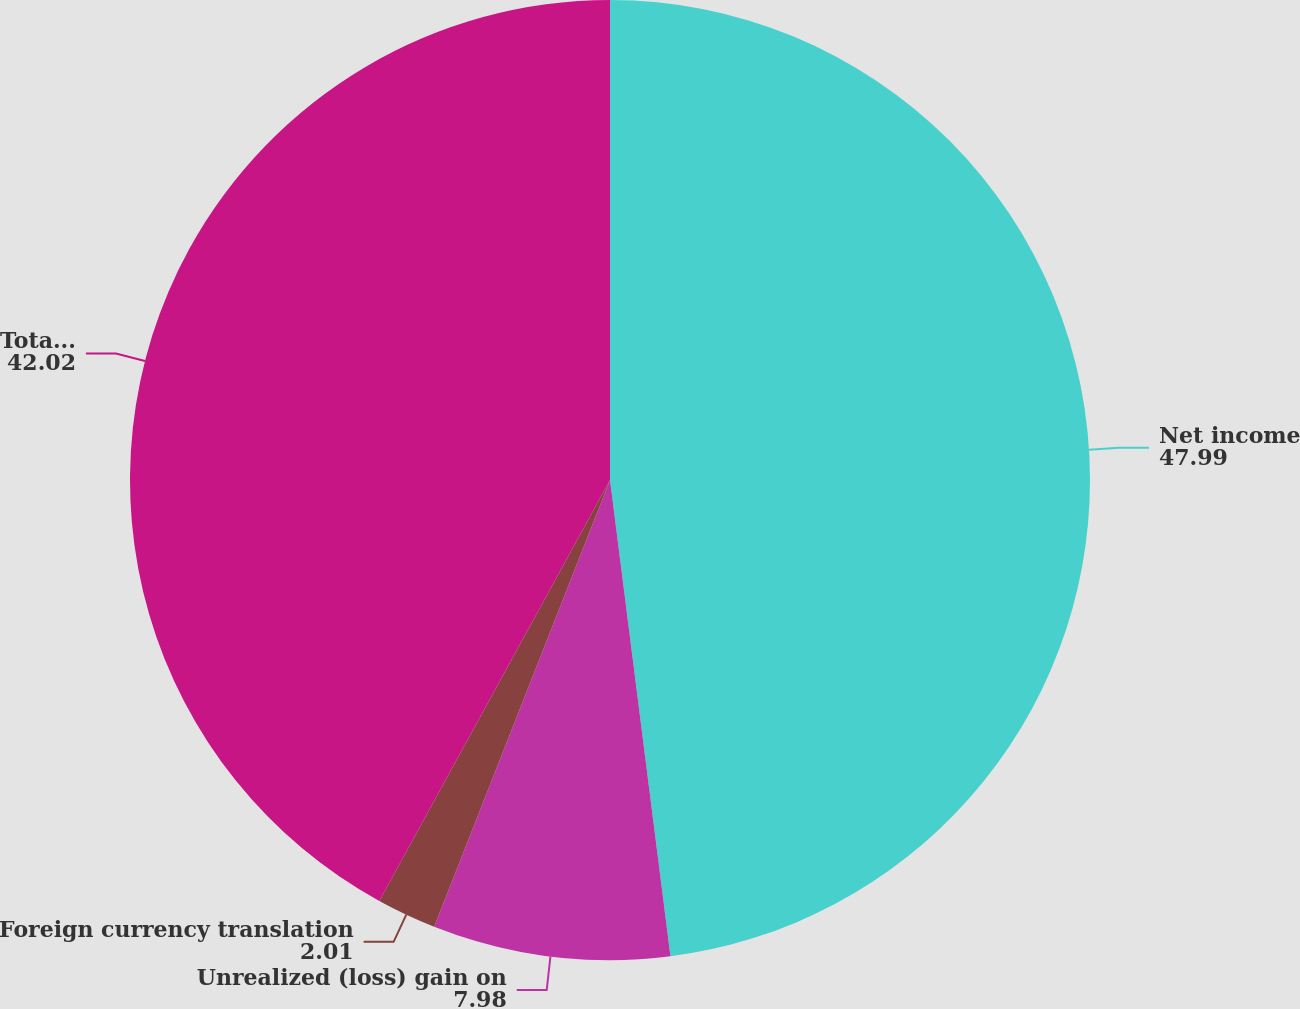Convert chart to OTSL. <chart><loc_0><loc_0><loc_500><loc_500><pie_chart><fcel>Net income<fcel>Unrealized (loss) gain on<fcel>Foreign currency translation<fcel>Total comprehensive income net<nl><fcel>47.99%<fcel>7.98%<fcel>2.01%<fcel>42.02%<nl></chart> 